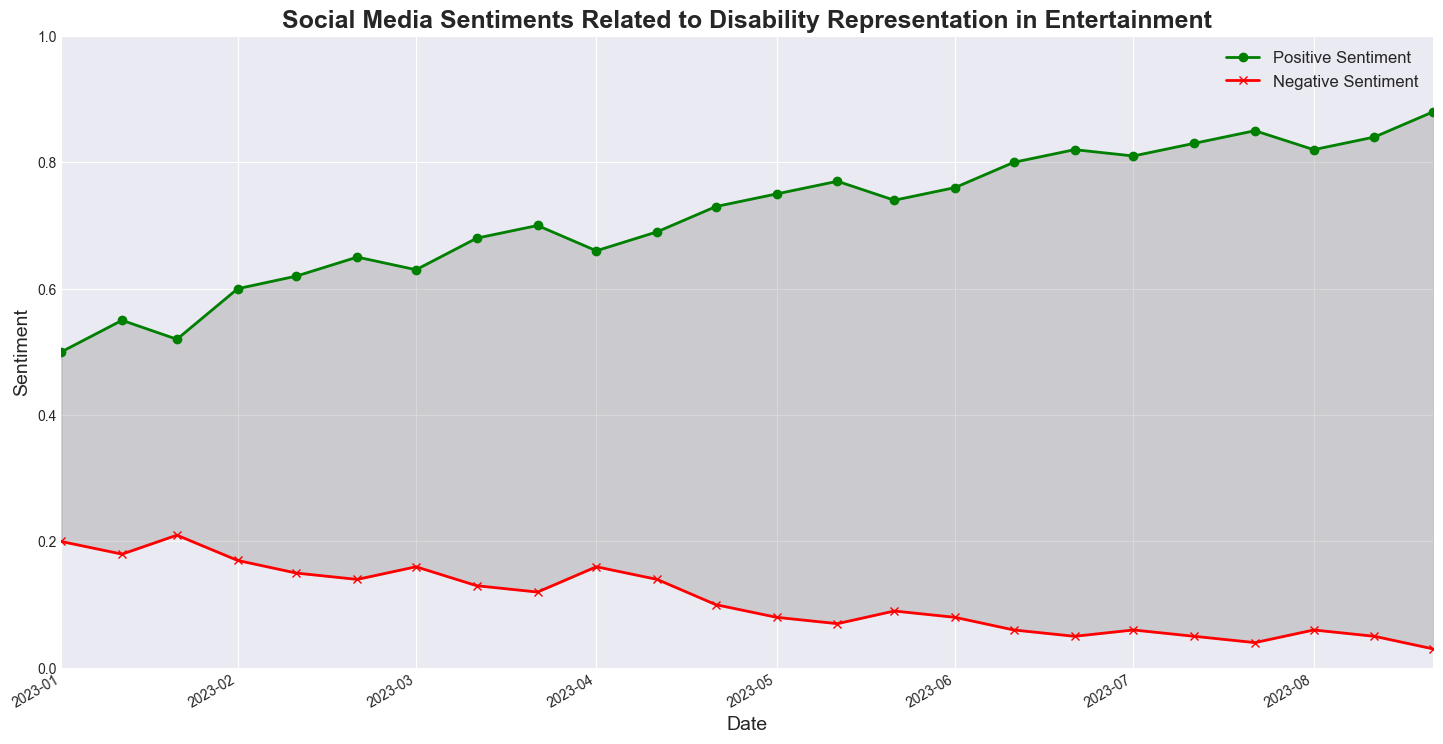what is the highest value of positive sentiment? To find the highest value of positive sentiment, look at the 'Positive Sentiment' line which is green and observe its peak. The highest value appears in December 2024.
Answer: 0.88 how did the negative sentiment change from January 2023 to January 2024? Observe the 'Negative Sentiment' line, which is red, at the points corresponding to January 2023 and January 2024. In January 2023, the value is 0.20, and in January 2024, it is 0.08. The change is calculated as 0.20 - 0.08.
Answer: Decreased by 0.12 what is the average positive sentiment from January to December 2024? List the values for positive sentiment from January to December 2024 and calculate the average: (0.75 + 0.77 + 0.74 + 0.76 + 0.80 + 0.82 + 0.81 + 0.83 + 0.85 + 0.82 + 0.84 + 0.88) / 12.
Answer: 0.80 which month has the smallest gap between positive and negative sentiments? To find the smallest gap, calculate the difference between the positive and negative sentiment values for each month and find the month with the minimum difference. For example, in December 2024, the difference is 0.88 - 0.03 = 0.85, and in February 2023, it is 0.55 - 0.18 = 0.37.
Answer: February 2023 what trend can be observed in positive sentiment from January 2023 to December 2024? Visually observe the green line representing positive sentiment. It generally shows an increasing trend from a lower value in January 2023 to a higher peak in December 2024.
Answer: Increasing how does the sentiment compare between October 2023 and February 2024? Examine both positive and negative sentiment values for October 2023 and February 2024. In October 2023, positive sentiment is 0.66 and negative is 0.16. In February 2024, positive sentiment is 0.77 and negative is 0.07. Compare the differences.
Answer: February 2024 has higher positive sentiment and lower negative sentiment what season shows the most significant increase in positive sentiment? Observe the green line and identify the season (e.g., Spring, Summer, Fall, Winter) where the slope of the line is steepest, indicating a significant increase. For example, Winter 2023 to Spring 2024 (December 2023 to May 2024) shows a steep increase.
Answer: Winter 2023 to Spring 2024 how does the sentiment shift around major awards seasons (January to March)? Compare positive and negative sentiments for the first quarter of each year. In 2023 and 2024, the positive sentiment increases, while negative sentiment decreases during these months.
Answer: Positive sentiment increases, negative sentiment decreases which month in 2024 has the lowest negative sentiment? Locate the red line for negative sentiment in 2024 and find the minimum value. November and August 2024 both have the same lower value (0.05), but December has the lowest (0.03).
Answer: December 2024 how much did the positive sentiment increase between January 2023 and January 2024? Locate the positive sentiment values for January 2023 (0.50) and January 2024 (0.75). The increase is calculated as 0.75 - 0.50.
Answer: Increased by 0.25 